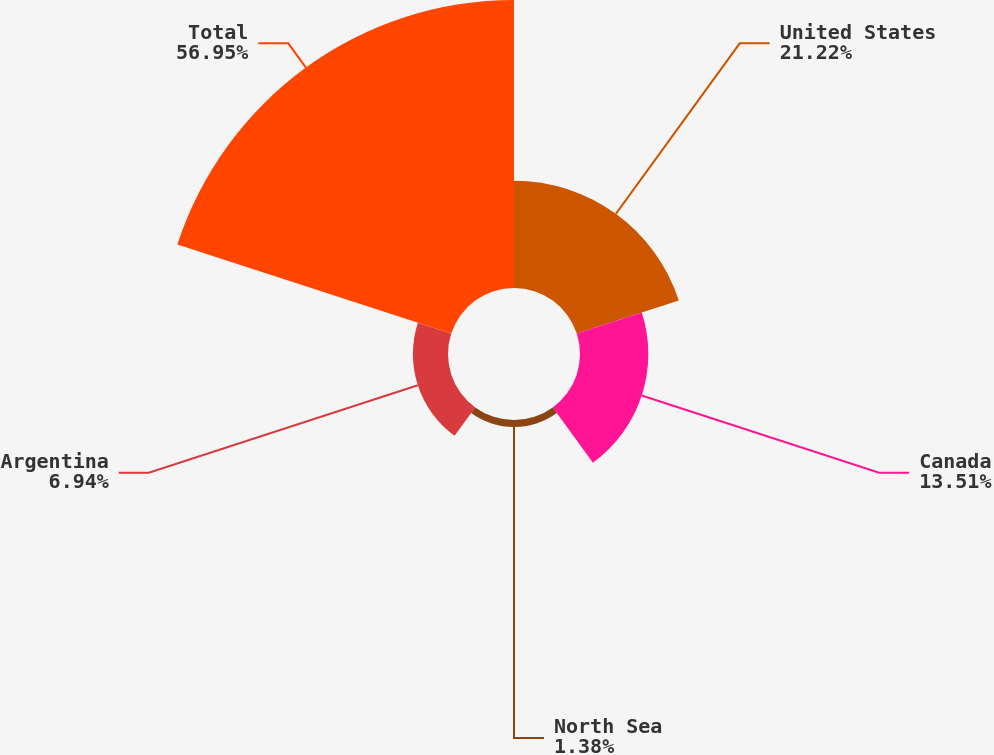Convert chart to OTSL. <chart><loc_0><loc_0><loc_500><loc_500><pie_chart><fcel>United States<fcel>Canada<fcel>North Sea<fcel>Argentina<fcel>Total<nl><fcel>21.22%<fcel>13.51%<fcel>1.38%<fcel>6.94%<fcel>56.95%<nl></chart> 